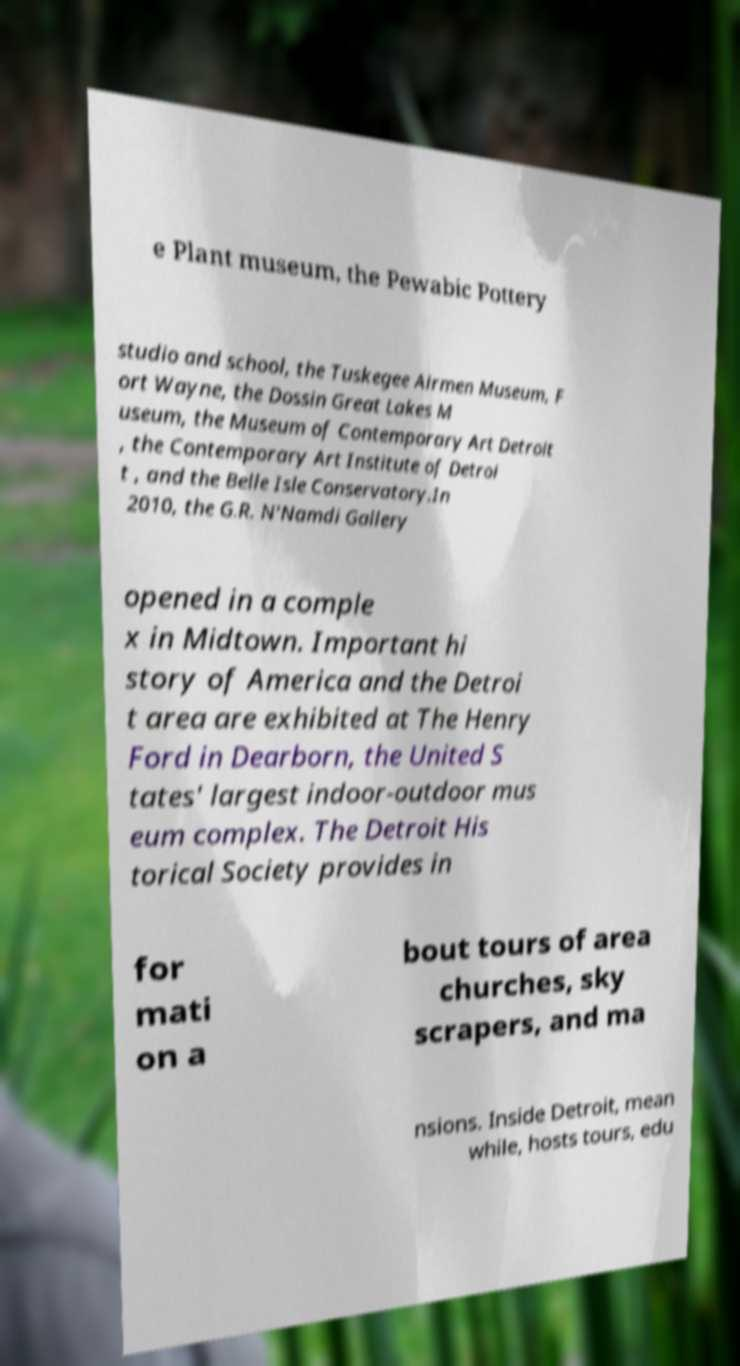For documentation purposes, I need the text within this image transcribed. Could you provide that? e Plant museum, the Pewabic Pottery studio and school, the Tuskegee Airmen Museum, F ort Wayne, the Dossin Great Lakes M useum, the Museum of Contemporary Art Detroit , the Contemporary Art Institute of Detroi t , and the Belle Isle Conservatory.In 2010, the G.R. N'Namdi Gallery opened in a comple x in Midtown. Important hi story of America and the Detroi t area are exhibited at The Henry Ford in Dearborn, the United S tates' largest indoor-outdoor mus eum complex. The Detroit His torical Society provides in for mati on a bout tours of area churches, sky scrapers, and ma nsions. Inside Detroit, mean while, hosts tours, edu 